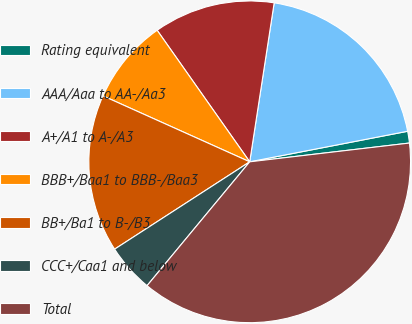<chart> <loc_0><loc_0><loc_500><loc_500><pie_chart><fcel>Rating equivalent<fcel>AAA/Aaa to AA-/Aa3<fcel>A+/A1 to A-/A3<fcel>BBB+/Baa1 to BBB-/Baa3<fcel>BB+/Ba1 to B-/B3<fcel>CCC+/Caa1 and below<fcel>Total<nl><fcel>1.18%<fcel>19.53%<fcel>12.19%<fcel>8.52%<fcel>15.86%<fcel>4.85%<fcel>37.88%<nl></chart> 